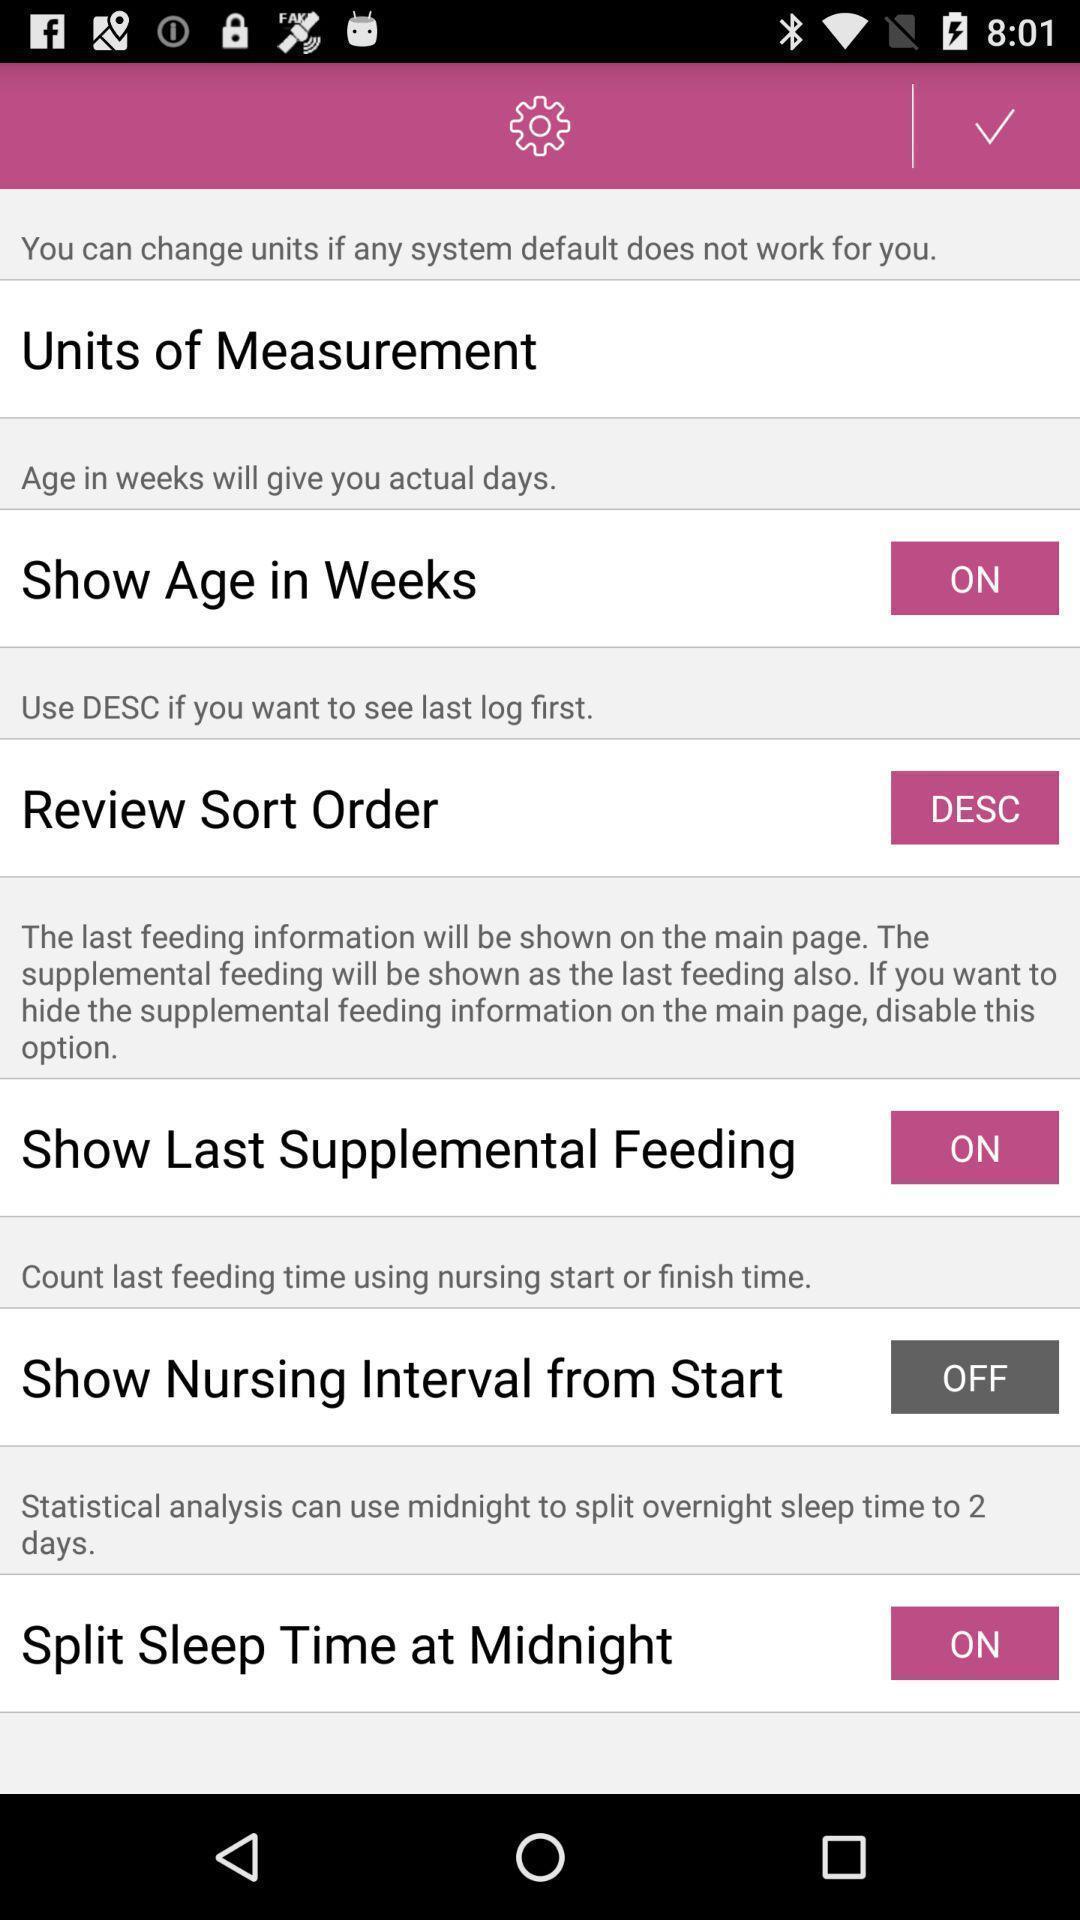Give me a summary of this screen capture. Settings page. 